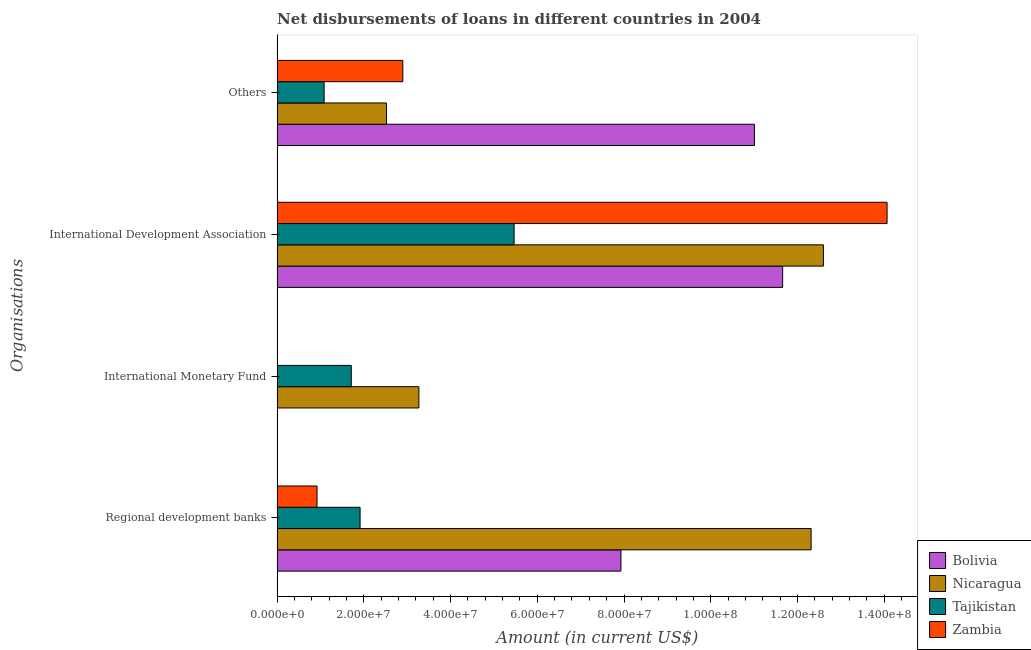Are the number of bars per tick equal to the number of legend labels?
Keep it short and to the point. No. How many bars are there on the 3rd tick from the top?
Keep it short and to the point. 2. What is the label of the 4th group of bars from the top?
Ensure brevity in your answer.  Regional development banks. What is the amount of loan disimbursed by international monetary fund in Tajikistan?
Make the answer very short. 1.71e+07. Across all countries, what is the maximum amount of loan disimbursed by other organisations?
Your answer should be very brief. 1.10e+08. Across all countries, what is the minimum amount of loan disimbursed by regional development banks?
Ensure brevity in your answer.  9.20e+06. In which country was the amount of loan disimbursed by international development association maximum?
Your response must be concise. Zambia. What is the total amount of loan disimbursed by international development association in the graph?
Provide a short and direct response. 4.38e+08. What is the difference between the amount of loan disimbursed by regional development banks in Tajikistan and that in Zambia?
Make the answer very short. 9.93e+06. What is the difference between the amount of loan disimbursed by international monetary fund in Nicaragua and the amount of loan disimbursed by other organisations in Bolivia?
Keep it short and to the point. -7.74e+07. What is the average amount of loan disimbursed by regional development banks per country?
Ensure brevity in your answer.  5.77e+07. What is the difference between the amount of loan disimbursed by regional development banks and amount of loan disimbursed by other organisations in Tajikistan?
Provide a short and direct response. 8.29e+06. In how many countries, is the amount of loan disimbursed by regional development banks greater than 48000000 US$?
Offer a very short reply. 2. What is the ratio of the amount of loan disimbursed by international development association in Zambia to that in Tajikistan?
Make the answer very short. 2.57. Is the difference between the amount of loan disimbursed by international development association in Bolivia and Zambia greater than the difference between the amount of loan disimbursed by other organisations in Bolivia and Zambia?
Make the answer very short. No. What is the difference between the highest and the second highest amount of loan disimbursed by other organisations?
Ensure brevity in your answer.  8.11e+07. What is the difference between the highest and the lowest amount of loan disimbursed by international monetary fund?
Offer a terse response. 3.27e+07. In how many countries, is the amount of loan disimbursed by international development association greater than the average amount of loan disimbursed by international development association taken over all countries?
Your response must be concise. 3. Is it the case that in every country, the sum of the amount of loan disimbursed by international monetary fund and amount of loan disimbursed by other organisations is greater than the sum of amount of loan disimbursed by regional development banks and amount of loan disimbursed by international development association?
Provide a succinct answer. No. Are all the bars in the graph horizontal?
Your answer should be compact. Yes. What is the title of the graph?
Ensure brevity in your answer.  Net disbursements of loans in different countries in 2004. What is the label or title of the Y-axis?
Provide a succinct answer. Organisations. What is the Amount (in current US$) in Bolivia in Regional development banks?
Give a very brief answer. 7.93e+07. What is the Amount (in current US$) in Nicaragua in Regional development banks?
Provide a short and direct response. 1.23e+08. What is the Amount (in current US$) in Tajikistan in Regional development banks?
Your answer should be very brief. 1.91e+07. What is the Amount (in current US$) of Zambia in Regional development banks?
Your response must be concise. 9.20e+06. What is the Amount (in current US$) of Bolivia in International Monetary Fund?
Ensure brevity in your answer.  0. What is the Amount (in current US$) of Nicaragua in International Monetary Fund?
Make the answer very short. 3.27e+07. What is the Amount (in current US$) of Tajikistan in International Monetary Fund?
Your response must be concise. 1.71e+07. What is the Amount (in current US$) of Zambia in International Monetary Fund?
Give a very brief answer. 0. What is the Amount (in current US$) in Bolivia in International Development Association?
Offer a very short reply. 1.17e+08. What is the Amount (in current US$) of Nicaragua in International Development Association?
Your answer should be compact. 1.26e+08. What is the Amount (in current US$) in Tajikistan in International Development Association?
Provide a short and direct response. 5.46e+07. What is the Amount (in current US$) of Zambia in International Development Association?
Provide a short and direct response. 1.41e+08. What is the Amount (in current US$) of Bolivia in Others?
Ensure brevity in your answer.  1.10e+08. What is the Amount (in current US$) in Nicaragua in Others?
Make the answer very short. 2.52e+07. What is the Amount (in current US$) of Tajikistan in Others?
Provide a succinct answer. 1.08e+07. What is the Amount (in current US$) in Zambia in Others?
Offer a very short reply. 2.90e+07. Across all Organisations, what is the maximum Amount (in current US$) in Bolivia?
Your answer should be compact. 1.17e+08. Across all Organisations, what is the maximum Amount (in current US$) of Nicaragua?
Keep it short and to the point. 1.26e+08. Across all Organisations, what is the maximum Amount (in current US$) in Tajikistan?
Keep it short and to the point. 5.46e+07. Across all Organisations, what is the maximum Amount (in current US$) in Zambia?
Provide a succinct answer. 1.41e+08. Across all Organisations, what is the minimum Amount (in current US$) of Bolivia?
Provide a succinct answer. 0. Across all Organisations, what is the minimum Amount (in current US$) in Nicaragua?
Your answer should be very brief. 2.52e+07. Across all Organisations, what is the minimum Amount (in current US$) of Tajikistan?
Keep it short and to the point. 1.08e+07. What is the total Amount (in current US$) of Bolivia in the graph?
Ensure brevity in your answer.  3.06e+08. What is the total Amount (in current US$) of Nicaragua in the graph?
Give a very brief answer. 3.07e+08. What is the total Amount (in current US$) in Tajikistan in the graph?
Make the answer very short. 1.02e+08. What is the total Amount (in current US$) in Zambia in the graph?
Provide a short and direct response. 1.79e+08. What is the difference between the Amount (in current US$) in Nicaragua in Regional development banks and that in International Monetary Fund?
Provide a succinct answer. 9.05e+07. What is the difference between the Amount (in current US$) in Tajikistan in Regional development banks and that in International Monetary Fund?
Your answer should be very brief. 2.03e+06. What is the difference between the Amount (in current US$) of Bolivia in Regional development banks and that in International Development Association?
Offer a very short reply. -3.73e+07. What is the difference between the Amount (in current US$) of Nicaragua in Regional development banks and that in International Development Association?
Your answer should be compact. -2.84e+06. What is the difference between the Amount (in current US$) in Tajikistan in Regional development banks and that in International Development Association?
Offer a very short reply. -3.55e+07. What is the difference between the Amount (in current US$) in Zambia in Regional development banks and that in International Development Association?
Ensure brevity in your answer.  -1.31e+08. What is the difference between the Amount (in current US$) in Bolivia in Regional development banks and that in Others?
Give a very brief answer. -3.08e+07. What is the difference between the Amount (in current US$) of Nicaragua in Regional development banks and that in Others?
Offer a terse response. 9.79e+07. What is the difference between the Amount (in current US$) in Tajikistan in Regional development banks and that in Others?
Provide a succinct answer. 8.29e+06. What is the difference between the Amount (in current US$) of Zambia in Regional development banks and that in Others?
Make the answer very short. -1.98e+07. What is the difference between the Amount (in current US$) in Nicaragua in International Monetary Fund and that in International Development Association?
Ensure brevity in your answer.  -9.33e+07. What is the difference between the Amount (in current US$) of Tajikistan in International Monetary Fund and that in International Development Association?
Provide a short and direct response. -3.75e+07. What is the difference between the Amount (in current US$) of Nicaragua in International Monetary Fund and that in Others?
Keep it short and to the point. 7.47e+06. What is the difference between the Amount (in current US$) in Tajikistan in International Monetary Fund and that in Others?
Provide a short and direct response. 6.26e+06. What is the difference between the Amount (in current US$) of Bolivia in International Development Association and that in Others?
Your answer should be very brief. 6.51e+06. What is the difference between the Amount (in current US$) in Nicaragua in International Development Association and that in Others?
Your answer should be compact. 1.01e+08. What is the difference between the Amount (in current US$) of Tajikistan in International Development Association and that in Others?
Your answer should be very brief. 4.38e+07. What is the difference between the Amount (in current US$) in Zambia in International Development Association and that in Others?
Give a very brief answer. 1.12e+08. What is the difference between the Amount (in current US$) in Bolivia in Regional development banks and the Amount (in current US$) in Nicaragua in International Monetary Fund?
Keep it short and to the point. 4.66e+07. What is the difference between the Amount (in current US$) in Bolivia in Regional development banks and the Amount (in current US$) in Tajikistan in International Monetary Fund?
Make the answer very short. 6.22e+07. What is the difference between the Amount (in current US$) of Nicaragua in Regional development banks and the Amount (in current US$) of Tajikistan in International Monetary Fund?
Offer a terse response. 1.06e+08. What is the difference between the Amount (in current US$) of Bolivia in Regional development banks and the Amount (in current US$) of Nicaragua in International Development Association?
Provide a short and direct response. -4.67e+07. What is the difference between the Amount (in current US$) of Bolivia in Regional development banks and the Amount (in current US$) of Tajikistan in International Development Association?
Ensure brevity in your answer.  2.46e+07. What is the difference between the Amount (in current US$) in Bolivia in Regional development banks and the Amount (in current US$) in Zambia in International Development Association?
Give a very brief answer. -6.14e+07. What is the difference between the Amount (in current US$) in Nicaragua in Regional development banks and the Amount (in current US$) in Tajikistan in International Development Association?
Provide a succinct answer. 6.85e+07. What is the difference between the Amount (in current US$) in Nicaragua in Regional development banks and the Amount (in current US$) in Zambia in International Development Association?
Keep it short and to the point. -1.75e+07. What is the difference between the Amount (in current US$) of Tajikistan in Regional development banks and the Amount (in current US$) of Zambia in International Development Association?
Provide a short and direct response. -1.22e+08. What is the difference between the Amount (in current US$) in Bolivia in Regional development banks and the Amount (in current US$) in Nicaragua in Others?
Give a very brief answer. 5.41e+07. What is the difference between the Amount (in current US$) in Bolivia in Regional development banks and the Amount (in current US$) in Tajikistan in Others?
Provide a short and direct response. 6.84e+07. What is the difference between the Amount (in current US$) in Bolivia in Regional development banks and the Amount (in current US$) in Zambia in Others?
Your answer should be very brief. 5.03e+07. What is the difference between the Amount (in current US$) of Nicaragua in Regional development banks and the Amount (in current US$) of Tajikistan in Others?
Make the answer very short. 1.12e+08. What is the difference between the Amount (in current US$) of Nicaragua in Regional development banks and the Amount (in current US$) of Zambia in Others?
Make the answer very short. 9.42e+07. What is the difference between the Amount (in current US$) of Tajikistan in Regional development banks and the Amount (in current US$) of Zambia in Others?
Provide a short and direct response. -9.86e+06. What is the difference between the Amount (in current US$) of Nicaragua in International Monetary Fund and the Amount (in current US$) of Tajikistan in International Development Association?
Your answer should be very brief. -2.20e+07. What is the difference between the Amount (in current US$) of Nicaragua in International Monetary Fund and the Amount (in current US$) of Zambia in International Development Association?
Give a very brief answer. -1.08e+08. What is the difference between the Amount (in current US$) in Tajikistan in International Monetary Fund and the Amount (in current US$) in Zambia in International Development Association?
Your response must be concise. -1.24e+08. What is the difference between the Amount (in current US$) of Nicaragua in International Monetary Fund and the Amount (in current US$) of Tajikistan in Others?
Ensure brevity in your answer.  2.18e+07. What is the difference between the Amount (in current US$) in Nicaragua in International Monetary Fund and the Amount (in current US$) in Zambia in Others?
Provide a short and direct response. 3.71e+06. What is the difference between the Amount (in current US$) in Tajikistan in International Monetary Fund and the Amount (in current US$) in Zambia in Others?
Provide a short and direct response. -1.19e+07. What is the difference between the Amount (in current US$) in Bolivia in International Development Association and the Amount (in current US$) in Nicaragua in Others?
Your answer should be very brief. 9.14e+07. What is the difference between the Amount (in current US$) in Bolivia in International Development Association and the Amount (in current US$) in Tajikistan in Others?
Your response must be concise. 1.06e+08. What is the difference between the Amount (in current US$) of Bolivia in International Development Association and the Amount (in current US$) of Zambia in Others?
Your answer should be compact. 8.76e+07. What is the difference between the Amount (in current US$) of Nicaragua in International Development Association and the Amount (in current US$) of Tajikistan in Others?
Provide a succinct answer. 1.15e+08. What is the difference between the Amount (in current US$) of Nicaragua in International Development Association and the Amount (in current US$) of Zambia in Others?
Make the answer very short. 9.70e+07. What is the difference between the Amount (in current US$) of Tajikistan in International Development Association and the Amount (in current US$) of Zambia in Others?
Offer a terse response. 2.57e+07. What is the average Amount (in current US$) in Bolivia per Organisations?
Provide a short and direct response. 7.65e+07. What is the average Amount (in current US$) of Nicaragua per Organisations?
Your response must be concise. 7.68e+07. What is the average Amount (in current US$) of Tajikistan per Organisations?
Your answer should be very brief. 2.54e+07. What is the average Amount (in current US$) of Zambia per Organisations?
Your answer should be compact. 4.47e+07. What is the difference between the Amount (in current US$) in Bolivia and Amount (in current US$) in Nicaragua in Regional development banks?
Provide a succinct answer. -4.39e+07. What is the difference between the Amount (in current US$) of Bolivia and Amount (in current US$) of Tajikistan in Regional development banks?
Provide a succinct answer. 6.02e+07. What is the difference between the Amount (in current US$) of Bolivia and Amount (in current US$) of Zambia in Regional development banks?
Keep it short and to the point. 7.01e+07. What is the difference between the Amount (in current US$) in Nicaragua and Amount (in current US$) in Tajikistan in Regional development banks?
Ensure brevity in your answer.  1.04e+08. What is the difference between the Amount (in current US$) in Nicaragua and Amount (in current US$) in Zambia in Regional development banks?
Keep it short and to the point. 1.14e+08. What is the difference between the Amount (in current US$) of Tajikistan and Amount (in current US$) of Zambia in Regional development banks?
Your answer should be compact. 9.93e+06. What is the difference between the Amount (in current US$) of Nicaragua and Amount (in current US$) of Tajikistan in International Monetary Fund?
Ensure brevity in your answer.  1.56e+07. What is the difference between the Amount (in current US$) in Bolivia and Amount (in current US$) in Nicaragua in International Development Association?
Give a very brief answer. -9.40e+06. What is the difference between the Amount (in current US$) in Bolivia and Amount (in current US$) in Tajikistan in International Development Association?
Your response must be concise. 6.19e+07. What is the difference between the Amount (in current US$) of Bolivia and Amount (in current US$) of Zambia in International Development Association?
Make the answer very short. -2.41e+07. What is the difference between the Amount (in current US$) of Nicaragua and Amount (in current US$) of Tajikistan in International Development Association?
Offer a very short reply. 7.13e+07. What is the difference between the Amount (in current US$) of Nicaragua and Amount (in current US$) of Zambia in International Development Association?
Keep it short and to the point. -1.47e+07. What is the difference between the Amount (in current US$) in Tajikistan and Amount (in current US$) in Zambia in International Development Association?
Offer a very short reply. -8.60e+07. What is the difference between the Amount (in current US$) in Bolivia and Amount (in current US$) in Nicaragua in Others?
Offer a terse response. 8.49e+07. What is the difference between the Amount (in current US$) of Bolivia and Amount (in current US$) of Tajikistan in Others?
Provide a short and direct response. 9.92e+07. What is the difference between the Amount (in current US$) in Bolivia and Amount (in current US$) in Zambia in Others?
Offer a very short reply. 8.11e+07. What is the difference between the Amount (in current US$) in Nicaragua and Amount (in current US$) in Tajikistan in Others?
Keep it short and to the point. 1.44e+07. What is the difference between the Amount (in current US$) of Nicaragua and Amount (in current US$) of Zambia in Others?
Offer a terse response. -3.76e+06. What is the difference between the Amount (in current US$) in Tajikistan and Amount (in current US$) in Zambia in Others?
Offer a very short reply. -1.81e+07. What is the ratio of the Amount (in current US$) in Nicaragua in Regional development banks to that in International Monetary Fund?
Your response must be concise. 3.77. What is the ratio of the Amount (in current US$) of Tajikistan in Regional development banks to that in International Monetary Fund?
Your answer should be very brief. 1.12. What is the ratio of the Amount (in current US$) of Bolivia in Regional development banks to that in International Development Association?
Your answer should be very brief. 0.68. What is the ratio of the Amount (in current US$) of Nicaragua in Regional development banks to that in International Development Association?
Give a very brief answer. 0.98. What is the ratio of the Amount (in current US$) of Tajikistan in Regional development banks to that in International Development Association?
Your answer should be very brief. 0.35. What is the ratio of the Amount (in current US$) in Zambia in Regional development banks to that in International Development Association?
Your response must be concise. 0.07. What is the ratio of the Amount (in current US$) in Bolivia in Regional development banks to that in Others?
Offer a terse response. 0.72. What is the ratio of the Amount (in current US$) in Nicaragua in Regional development banks to that in Others?
Ensure brevity in your answer.  4.88. What is the ratio of the Amount (in current US$) in Tajikistan in Regional development banks to that in Others?
Your response must be concise. 1.76. What is the ratio of the Amount (in current US$) of Zambia in Regional development banks to that in Others?
Your answer should be compact. 0.32. What is the ratio of the Amount (in current US$) in Nicaragua in International Monetary Fund to that in International Development Association?
Give a very brief answer. 0.26. What is the ratio of the Amount (in current US$) of Tajikistan in International Monetary Fund to that in International Development Association?
Ensure brevity in your answer.  0.31. What is the ratio of the Amount (in current US$) in Nicaragua in International Monetary Fund to that in Others?
Provide a short and direct response. 1.3. What is the ratio of the Amount (in current US$) of Tajikistan in International Monetary Fund to that in Others?
Offer a terse response. 1.58. What is the ratio of the Amount (in current US$) in Bolivia in International Development Association to that in Others?
Your response must be concise. 1.06. What is the ratio of the Amount (in current US$) of Nicaragua in International Development Association to that in Others?
Ensure brevity in your answer.  5. What is the ratio of the Amount (in current US$) in Tajikistan in International Development Association to that in Others?
Make the answer very short. 5.04. What is the ratio of the Amount (in current US$) in Zambia in International Development Association to that in Others?
Your response must be concise. 4.85. What is the difference between the highest and the second highest Amount (in current US$) of Bolivia?
Your answer should be compact. 6.51e+06. What is the difference between the highest and the second highest Amount (in current US$) in Nicaragua?
Your response must be concise. 2.84e+06. What is the difference between the highest and the second highest Amount (in current US$) of Tajikistan?
Keep it short and to the point. 3.55e+07. What is the difference between the highest and the second highest Amount (in current US$) of Zambia?
Keep it short and to the point. 1.12e+08. What is the difference between the highest and the lowest Amount (in current US$) of Bolivia?
Make the answer very short. 1.17e+08. What is the difference between the highest and the lowest Amount (in current US$) in Nicaragua?
Offer a very short reply. 1.01e+08. What is the difference between the highest and the lowest Amount (in current US$) in Tajikistan?
Give a very brief answer. 4.38e+07. What is the difference between the highest and the lowest Amount (in current US$) of Zambia?
Make the answer very short. 1.41e+08. 